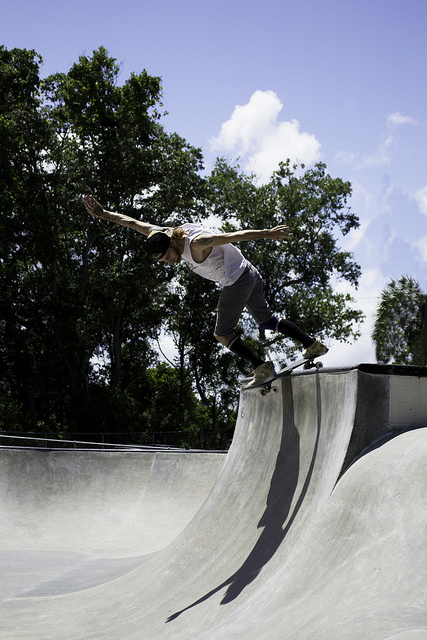<image>What is his head protection? I don't know what his head protection is. It can be a baseball cap, helmet, or hat. What is his head protection? I am not sure what is his head protection. It can be seen as 'baseball cap', 'helmet', 'none', or 'hat'. 